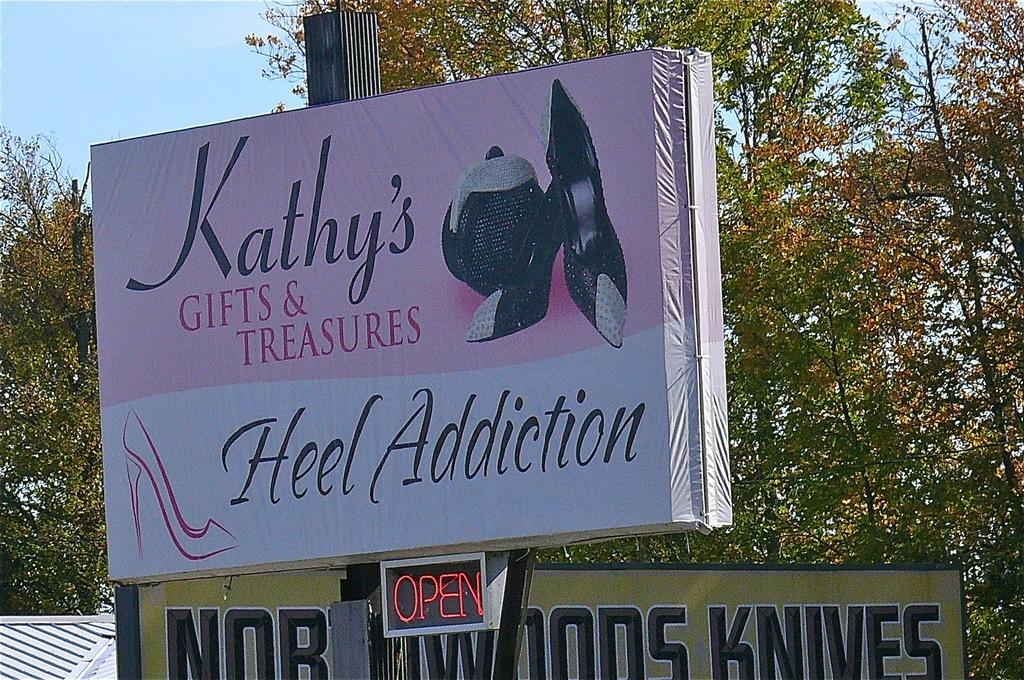What is the name of the store?
Offer a very short reply. Kathy's gifts & treasures. 